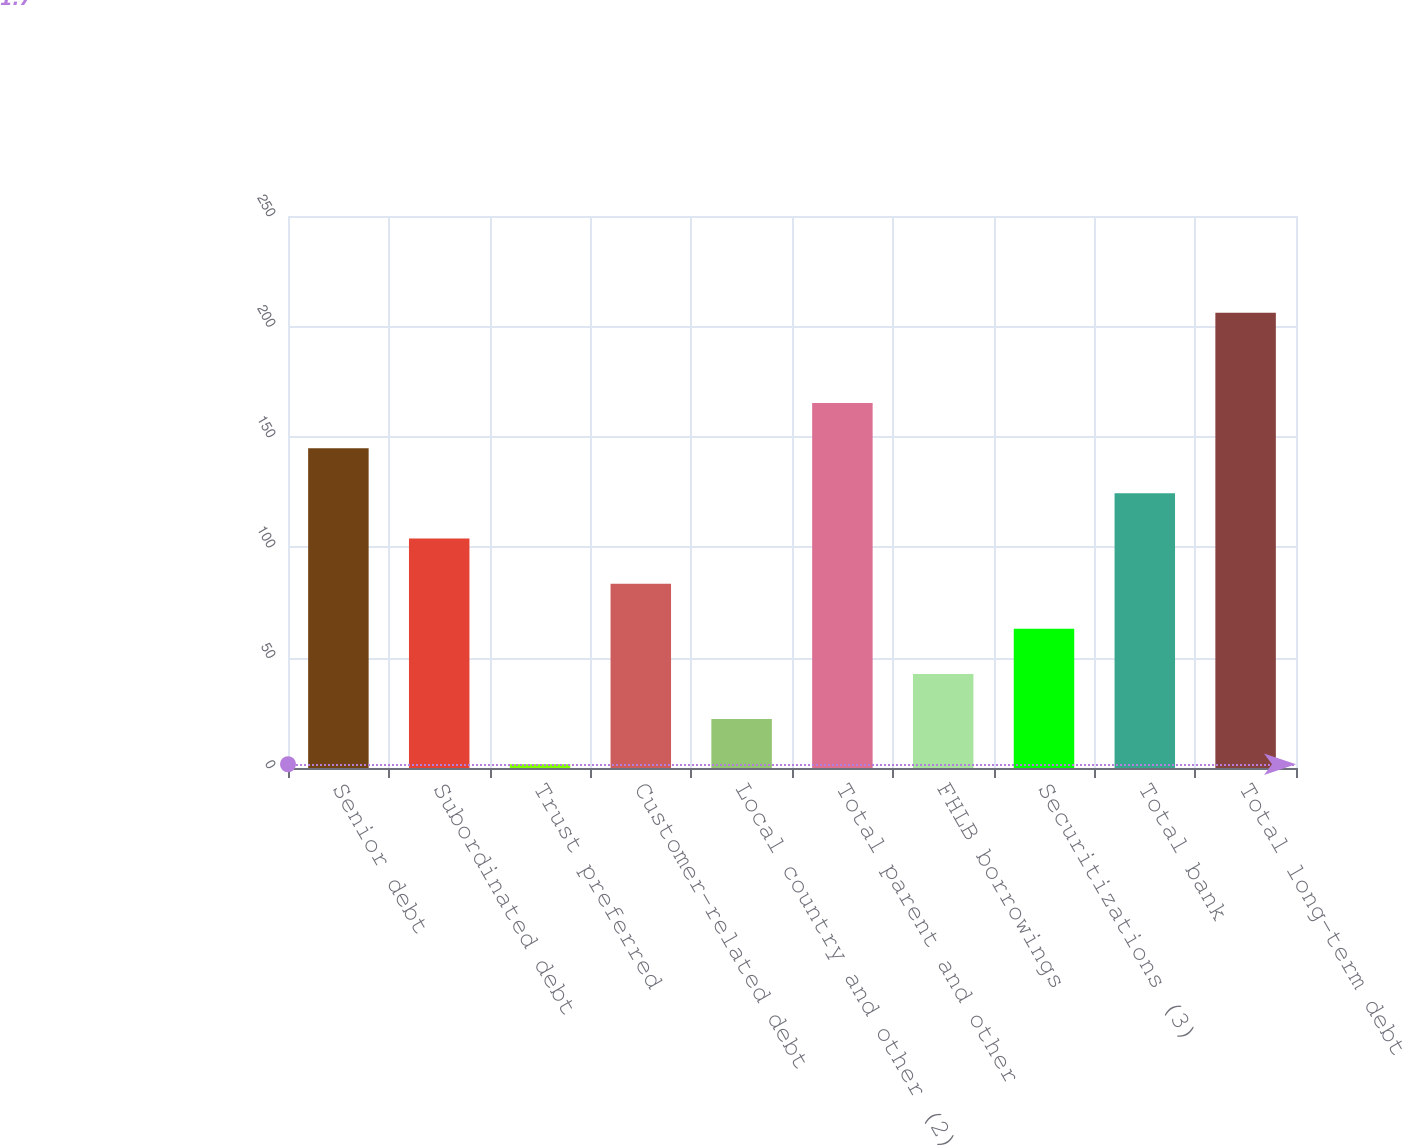Convert chart to OTSL. <chart><loc_0><loc_0><loc_500><loc_500><bar_chart><fcel>Senior debt<fcel>Subordinated debt<fcel>Trust preferred<fcel>Customer-related debt<fcel>Local country and other (2)<fcel>Total parent and other<fcel>FHLB borrowings<fcel>Securitizations (3)<fcel>Total bank<fcel>Total long-term debt<nl><fcel>144.85<fcel>103.95<fcel>1.7<fcel>83.5<fcel>22.15<fcel>165.3<fcel>42.6<fcel>63.05<fcel>124.4<fcel>206.2<nl></chart> 